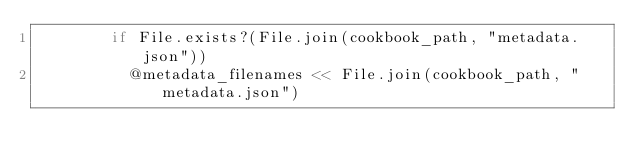<code> <loc_0><loc_0><loc_500><loc_500><_Ruby_>        if File.exists?(File.join(cookbook_path, "metadata.json"))
          @metadata_filenames << File.join(cookbook_path, "metadata.json")</code> 